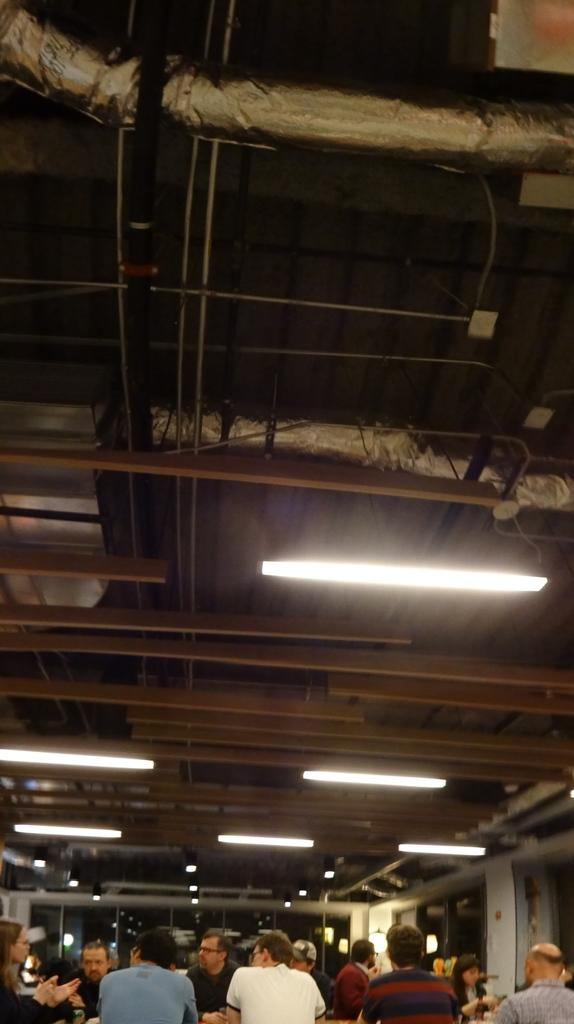Who or what can be seen in the image? There are people in the image. What structure is located at the top of the image? There is a shed at the top of the image. What can be used to provide illumination in the image? There are lights visible in the image. What country is the face of the partner from in the image? There is no face or partner present in the image, so this information cannot be determined. 